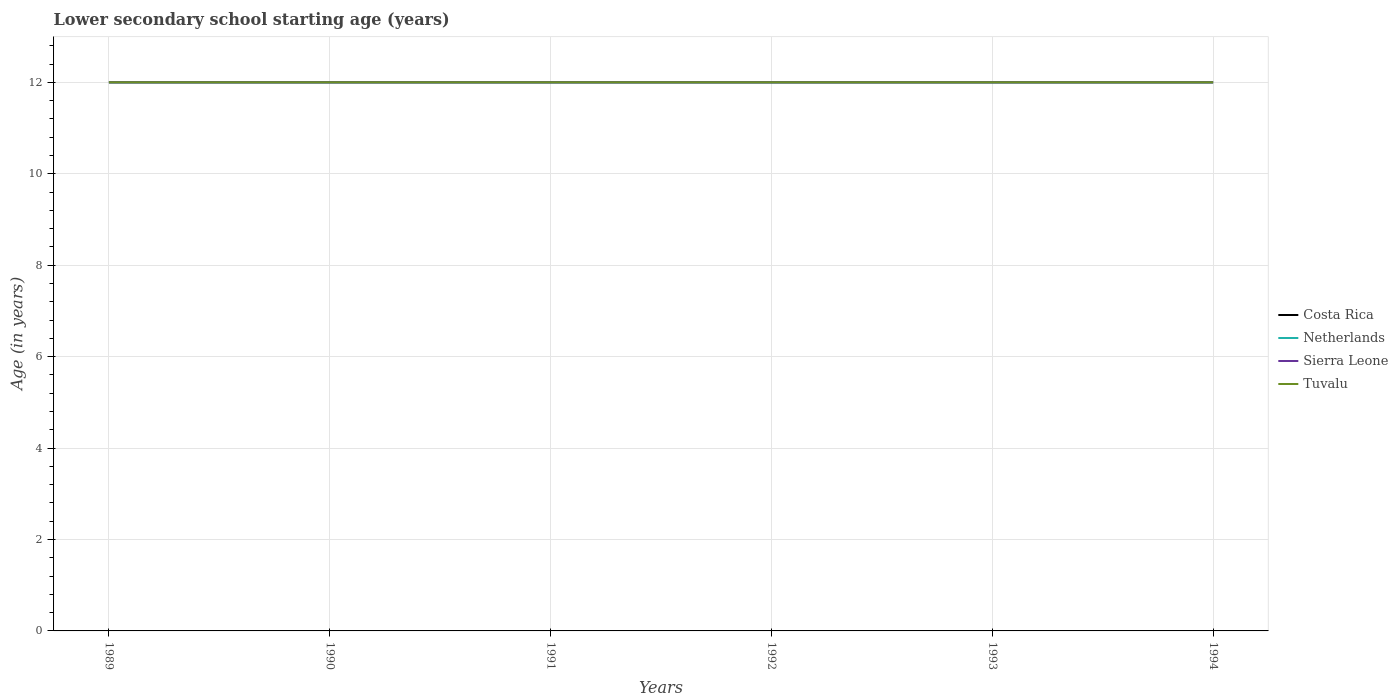Is the number of lines equal to the number of legend labels?
Your answer should be compact. Yes. What is the difference between the highest and the second highest lower secondary school starting age of children in Costa Rica?
Keep it short and to the point. 0. Is the lower secondary school starting age of children in Netherlands strictly greater than the lower secondary school starting age of children in Sierra Leone over the years?
Provide a succinct answer. No. Are the values on the major ticks of Y-axis written in scientific E-notation?
Offer a very short reply. No. Does the graph contain any zero values?
Offer a terse response. No. Where does the legend appear in the graph?
Offer a terse response. Center right. How many legend labels are there?
Offer a terse response. 4. How are the legend labels stacked?
Your answer should be compact. Vertical. What is the title of the graph?
Ensure brevity in your answer.  Lower secondary school starting age (years). Does "Vietnam" appear as one of the legend labels in the graph?
Offer a terse response. No. What is the label or title of the X-axis?
Offer a terse response. Years. What is the label or title of the Y-axis?
Your answer should be compact. Age (in years). What is the Age (in years) of Costa Rica in 1989?
Make the answer very short. 12. What is the Age (in years) of Netherlands in 1989?
Offer a terse response. 12. What is the Age (in years) of Tuvalu in 1989?
Make the answer very short. 12. What is the Age (in years) of Costa Rica in 1990?
Ensure brevity in your answer.  12. What is the Age (in years) of Netherlands in 1990?
Your answer should be compact. 12. What is the Age (in years) in Sierra Leone in 1990?
Offer a very short reply. 12. What is the Age (in years) in Netherlands in 1991?
Offer a terse response. 12. What is the Age (in years) of Tuvalu in 1991?
Give a very brief answer. 12. What is the Age (in years) in Costa Rica in 1992?
Offer a very short reply. 12. What is the Age (in years) of Netherlands in 1993?
Provide a short and direct response. 12. What is the Age (in years) of Costa Rica in 1994?
Keep it short and to the point. 12. What is the Age (in years) of Netherlands in 1994?
Offer a terse response. 12. What is the Age (in years) in Tuvalu in 1994?
Your response must be concise. 12. Across all years, what is the maximum Age (in years) of Netherlands?
Offer a very short reply. 12. Across all years, what is the maximum Age (in years) of Tuvalu?
Provide a succinct answer. 12. Across all years, what is the minimum Age (in years) in Costa Rica?
Offer a terse response. 12. Across all years, what is the minimum Age (in years) in Netherlands?
Your response must be concise. 12. Across all years, what is the minimum Age (in years) of Sierra Leone?
Your answer should be compact. 12. Across all years, what is the minimum Age (in years) in Tuvalu?
Give a very brief answer. 12. What is the total Age (in years) of Costa Rica in the graph?
Offer a very short reply. 72. What is the total Age (in years) in Netherlands in the graph?
Provide a short and direct response. 72. What is the total Age (in years) in Sierra Leone in the graph?
Keep it short and to the point. 72. What is the difference between the Age (in years) of Costa Rica in 1989 and that in 1991?
Provide a short and direct response. 0. What is the difference between the Age (in years) in Sierra Leone in 1989 and that in 1991?
Ensure brevity in your answer.  0. What is the difference between the Age (in years) of Netherlands in 1989 and that in 1992?
Your answer should be very brief. 0. What is the difference between the Age (in years) of Sierra Leone in 1989 and that in 1992?
Your answer should be compact. 0. What is the difference between the Age (in years) of Netherlands in 1989 and that in 1993?
Ensure brevity in your answer.  0. What is the difference between the Age (in years) in Sierra Leone in 1989 and that in 1993?
Offer a terse response. 0. What is the difference between the Age (in years) of Sierra Leone in 1989 and that in 1994?
Your answer should be very brief. 0. What is the difference between the Age (in years) of Netherlands in 1990 and that in 1991?
Provide a short and direct response. 0. What is the difference between the Age (in years) in Netherlands in 1990 and that in 1992?
Offer a terse response. 0. What is the difference between the Age (in years) of Tuvalu in 1990 and that in 1992?
Your answer should be very brief. 0. What is the difference between the Age (in years) in Costa Rica in 1990 and that in 1993?
Give a very brief answer. 0. What is the difference between the Age (in years) of Costa Rica in 1990 and that in 1994?
Offer a terse response. 0. What is the difference between the Age (in years) of Costa Rica in 1991 and that in 1992?
Make the answer very short. 0. What is the difference between the Age (in years) in Netherlands in 1991 and that in 1992?
Provide a succinct answer. 0. What is the difference between the Age (in years) in Sierra Leone in 1991 and that in 1992?
Offer a very short reply. 0. What is the difference between the Age (in years) in Tuvalu in 1991 and that in 1992?
Keep it short and to the point. 0. What is the difference between the Age (in years) in Netherlands in 1991 and that in 1993?
Your answer should be compact. 0. What is the difference between the Age (in years) of Tuvalu in 1991 and that in 1993?
Offer a very short reply. 0. What is the difference between the Age (in years) in Sierra Leone in 1991 and that in 1994?
Your response must be concise. 0. What is the difference between the Age (in years) of Costa Rica in 1992 and that in 1993?
Make the answer very short. 0. What is the difference between the Age (in years) in Netherlands in 1992 and that in 1993?
Provide a succinct answer. 0. What is the difference between the Age (in years) of Netherlands in 1992 and that in 1994?
Offer a terse response. 0. What is the difference between the Age (in years) in Sierra Leone in 1992 and that in 1994?
Ensure brevity in your answer.  0. What is the difference between the Age (in years) in Tuvalu in 1992 and that in 1994?
Your answer should be compact. 0. What is the difference between the Age (in years) of Tuvalu in 1993 and that in 1994?
Ensure brevity in your answer.  0. What is the difference between the Age (in years) in Costa Rica in 1989 and the Age (in years) in Netherlands in 1990?
Offer a terse response. 0. What is the difference between the Age (in years) in Costa Rica in 1989 and the Age (in years) in Tuvalu in 1990?
Provide a succinct answer. 0. What is the difference between the Age (in years) in Netherlands in 1989 and the Age (in years) in Sierra Leone in 1990?
Make the answer very short. 0. What is the difference between the Age (in years) in Sierra Leone in 1989 and the Age (in years) in Tuvalu in 1990?
Offer a terse response. 0. What is the difference between the Age (in years) in Costa Rica in 1989 and the Age (in years) in Tuvalu in 1991?
Offer a terse response. 0. What is the difference between the Age (in years) in Netherlands in 1989 and the Age (in years) in Sierra Leone in 1991?
Keep it short and to the point. 0. What is the difference between the Age (in years) in Netherlands in 1989 and the Age (in years) in Tuvalu in 1991?
Your response must be concise. 0. What is the difference between the Age (in years) of Sierra Leone in 1989 and the Age (in years) of Tuvalu in 1991?
Keep it short and to the point. 0. What is the difference between the Age (in years) of Costa Rica in 1989 and the Age (in years) of Netherlands in 1992?
Your response must be concise. 0. What is the difference between the Age (in years) in Netherlands in 1989 and the Age (in years) in Tuvalu in 1992?
Give a very brief answer. 0. What is the difference between the Age (in years) in Costa Rica in 1989 and the Age (in years) in Netherlands in 1993?
Offer a very short reply. 0. What is the difference between the Age (in years) of Costa Rica in 1989 and the Age (in years) of Tuvalu in 1993?
Ensure brevity in your answer.  0. What is the difference between the Age (in years) in Netherlands in 1989 and the Age (in years) in Sierra Leone in 1993?
Offer a terse response. 0. What is the difference between the Age (in years) in Costa Rica in 1989 and the Age (in years) in Netherlands in 1994?
Ensure brevity in your answer.  0. What is the difference between the Age (in years) of Costa Rica in 1989 and the Age (in years) of Tuvalu in 1994?
Offer a very short reply. 0. What is the difference between the Age (in years) in Costa Rica in 1990 and the Age (in years) in Netherlands in 1991?
Make the answer very short. 0. What is the difference between the Age (in years) in Costa Rica in 1990 and the Age (in years) in Tuvalu in 1991?
Give a very brief answer. 0. What is the difference between the Age (in years) of Netherlands in 1990 and the Age (in years) of Sierra Leone in 1991?
Offer a terse response. 0. What is the difference between the Age (in years) of Costa Rica in 1990 and the Age (in years) of Sierra Leone in 1992?
Provide a succinct answer. 0. What is the difference between the Age (in years) of Netherlands in 1990 and the Age (in years) of Sierra Leone in 1992?
Your response must be concise. 0. What is the difference between the Age (in years) of Sierra Leone in 1990 and the Age (in years) of Tuvalu in 1992?
Make the answer very short. 0. What is the difference between the Age (in years) of Costa Rica in 1990 and the Age (in years) of Netherlands in 1993?
Give a very brief answer. 0. What is the difference between the Age (in years) of Costa Rica in 1990 and the Age (in years) of Tuvalu in 1993?
Your answer should be compact. 0. What is the difference between the Age (in years) of Netherlands in 1990 and the Age (in years) of Sierra Leone in 1993?
Ensure brevity in your answer.  0. What is the difference between the Age (in years) in Netherlands in 1990 and the Age (in years) in Tuvalu in 1993?
Ensure brevity in your answer.  0. What is the difference between the Age (in years) of Sierra Leone in 1990 and the Age (in years) of Tuvalu in 1993?
Keep it short and to the point. 0. What is the difference between the Age (in years) of Costa Rica in 1990 and the Age (in years) of Netherlands in 1994?
Offer a terse response. 0. What is the difference between the Age (in years) in Costa Rica in 1990 and the Age (in years) in Sierra Leone in 1994?
Offer a terse response. 0. What is the difference between the Age (in years) of Netherlands in 1990 and the Age (in years) of Sierra Leone in 1994?
Your answer should be very brief. 0. What is the difference between the Age (in years) in Sierra Leone in 1990 and the Age (in years) in Tuvalu in 1994?
Your answer should be compact. 0. What is the difference between the Age (in years) of Costa Rica in 1991 and the Age (in years) of Netherlands in 1992?
Your answer should be very brief. 0. What is the difference between the Age (in years) in Netherlands in 1991 and the Age (in years) in Sierra Leone in 1993?
Give a very brief answer. 0. What is the difference between the Age (in years) in Netherlands in 1991 and the Age (in years) in Tuvalu in 1993?
Keep it short and to the point. 0. What is the difference between the Age (in years) of Costa Rica in 1991 and the Age (in years) of Netherlands in 1994?
Ensure brevity in your answer.  0. What is the difference between the Age (in years) of Costa Rica in 1991 and the Age (in years) of Sierra Leone in 1994?
Your answer should be very brief. 0. What is the difference between the Age (in years) in Costa Rica in 1991 and the Age (in years) in Tuvalu in 1994?
Keep it short and to the point. 0. What is the difference between the Age (in years) of Netherlands in 1991 and the Age (in years) of Sierra Leone in 1994?
Provide a short and direct response. 0. What is the difference between the Age (in years) of Costa Rica in 1992 and the Age (in years) of Netherlands in 1993?
Your answer should be compact. 0. What is the difference between the Age (in years) of Costa Rica in 1992 and the Age (in years) of Sierra Leone in 1993?
Ensure brevity in your answer.  0. What is the difference between the Age (in years) in Sierra Leone in 1992 and the Age (in years) in Tuvalu in 1993?
Offer a terse response. 0. What is the difference between the Age (in years) in Costa Rica in 1992 and the Age (in years) in Tuvalu in 1994?
Make the answer very short. 0. What is the difference between the Age (in years) in Netherlands in 1993 and the Age (in years) in Tuvalu in 1994?
Your answer should be compact. 0. What is the average Age (in years) in Netherlands per year?
Provide a succinct answer. 12. What is the average Age (in years) in Tuvalu per year?
Keep it short and to the point. 12. In the year 1989, what is the difference between the Age (in years) in Costa Rica and Age (in years) in Netherlands?
Your response must be concise. 0. In the year 1989, what is the difference between the Age (in years) in Costa Rica and Age (in years) in Sierra Leone?
Offer a very short reply. 0. In the year 1990, what is the difference between the Age (in years) in Costa Rica and Age (in years) in Netherlands?
Keep it short and to the point. 0. In the year 1990, what is the difference between the Age (in years) of Costa Rica and Age (in years) of Sierra Leone?
Offer a very short reply. 0. In the year 1990, what is the difference between the Age (in years) in Sierra Leone and Age (in years) in Tuvalu?
Provide a succinct answer. 0. In the year 1991, what is the difference between the Age (in years) of Netherlands and Age (in years) of Sierra Leone?
Ensure brevity in your answer.  0. In the year 1991, what is the difference between the Age (in years) of Netherlands and Age (in years) of Tuvalu?
Provide a short and direct response. 0. In the year 1992, what is the difference between the Age (in years) in Costa Rica and Age (in years) in Netherlands?
Ensure brevity in your answer.  0. In the year 1992, what is the difference between the Age (in years) in Netherlands and Age (in years) in Sierra Leone?
Make the answer very short. 0. In the year 1992, what is the difference between the Age (in years) in Netherlands and Age (in years) in Tuvalu?
Ensure brevity in your answer.  0. In the year 1993, what is the difference between the Age (in years) in Costa Rica and Age (in years) in Tuvalu?
Give a very brief answer. 0. In the year 1993, what is the difference between the Age (in years) in Netherlands and Age (in years) in Tuvalu?
Provide a short and direct response. 0. In the year 1994, what is the difference between the Age (in years) of Costa Rica and Age (in years) of Sierra Leone?
Keep it short and to the point. 0. In the year 1994, what is the difference between the Age (in years) in Costa Rica and Age (in years) in Tuvalu?
Offer a terse response. 0. In the year 1994, what is the difference between the Age (in years) in Netherlands and Age (in years) in Sierra Leone?
Keep it short and to the point. 0. In the year 1994, what is the difference between the Age (in years) of Netherlands and Age (in years) of Tuvalu?
Keep it short and to the point. 0. What is the ratio of the Age (in years) of Sierra Leone in 1989 to that in 1990?
Offer a terse response. 1. What is the ratio of the Age (in years) in Tuvalu in 1989 to that in 1991?
Provide a short and direct response. 1. What is the ratio of the Age (in years) of Netherlands in 1989 to that in 1992?
Give a very brief answer. 1. What is the ratio of the Age (in years) in Costa Rica in 1989 to that in 1993?
Keep it short and to the point. 1. What is the ratio of the Age (in years) in Netherlands in 1989 to that in 1993?
Your answer should be very brief. 1. What is the ratio of the Age (in years) of Tuvalu in 1989 to that in 1993?
Provide a short and direct response. 1. What is the ratio of the Age (in years) of Costa Rica in 1989 to that in 1994?
Make the answer very short. 1. What is the ratio of the Age (in years) of Netherlands in 1989 to that in 1994?
Your response must be concise. 1. What is the ratio of the Age (in years) of Sierra Leone in 1989 to that in 1994?
Offer a terse response. 1. What is the ratio of the Age (in years) of Tuvalu in 1989 to that in 1994?
Your response must be concise. 1. What is the ratio of the Age (in years) of Tuvalu in 1990 to that in 1992?
Your response must be concise. 1. What is the ratio of the Age (in years) in Costa Rica in 1990 to that in 1993?
Offer a very short reply. 1. What is the ratio of the Age (in years) in Netherlands in 1990 to that in 1993?
Your answer should be compact. 1. What is the ratio of the Age (in years) of Costa Rica in 1991 to that in 1992?
Give a very brief answer. 1. What is the ratio of the Age (in years) of Tuvalu in 1991 to that in 1992?
Give a very brief answer. 1. What is the ratio of the Age (in years) in Sierra Leone in 1991 to that in 1993?
Your response must be concise. 1. What is the ratio of the Age (in years) in Costa Rica in 1991 to that in 1994?
Offer a very short reply. 1. What is the ratio of the Age (in years) in Sierra Leone in 1991 to that in 1994?
Offer a terse response. 1. What is the ratio of the Age (in years) in Costa Rica in 1992 to that in 1993?
Your response must be concise. 1. What is the ratio of the Age (in years) of Netherlands in 1992 to that in 1993?
Make the answer very short. 1. What is the ratio of the Age (in years) in Tuvalu in 1992 to that in 1993?
Your answer should be compact. 1. What is the ratio of the Age (in years) of Sierra Leone in 1992 to that in 1994?
Offer a terse response. 1. What is the ratio of the Age (in years) in Costa Rica in 1993 to that in 1994?
Offer a very short reply. 1. What is the difference between the highest and the lowest Age (in years) of Sierra Leone?
Your answer should be compact. 0. 